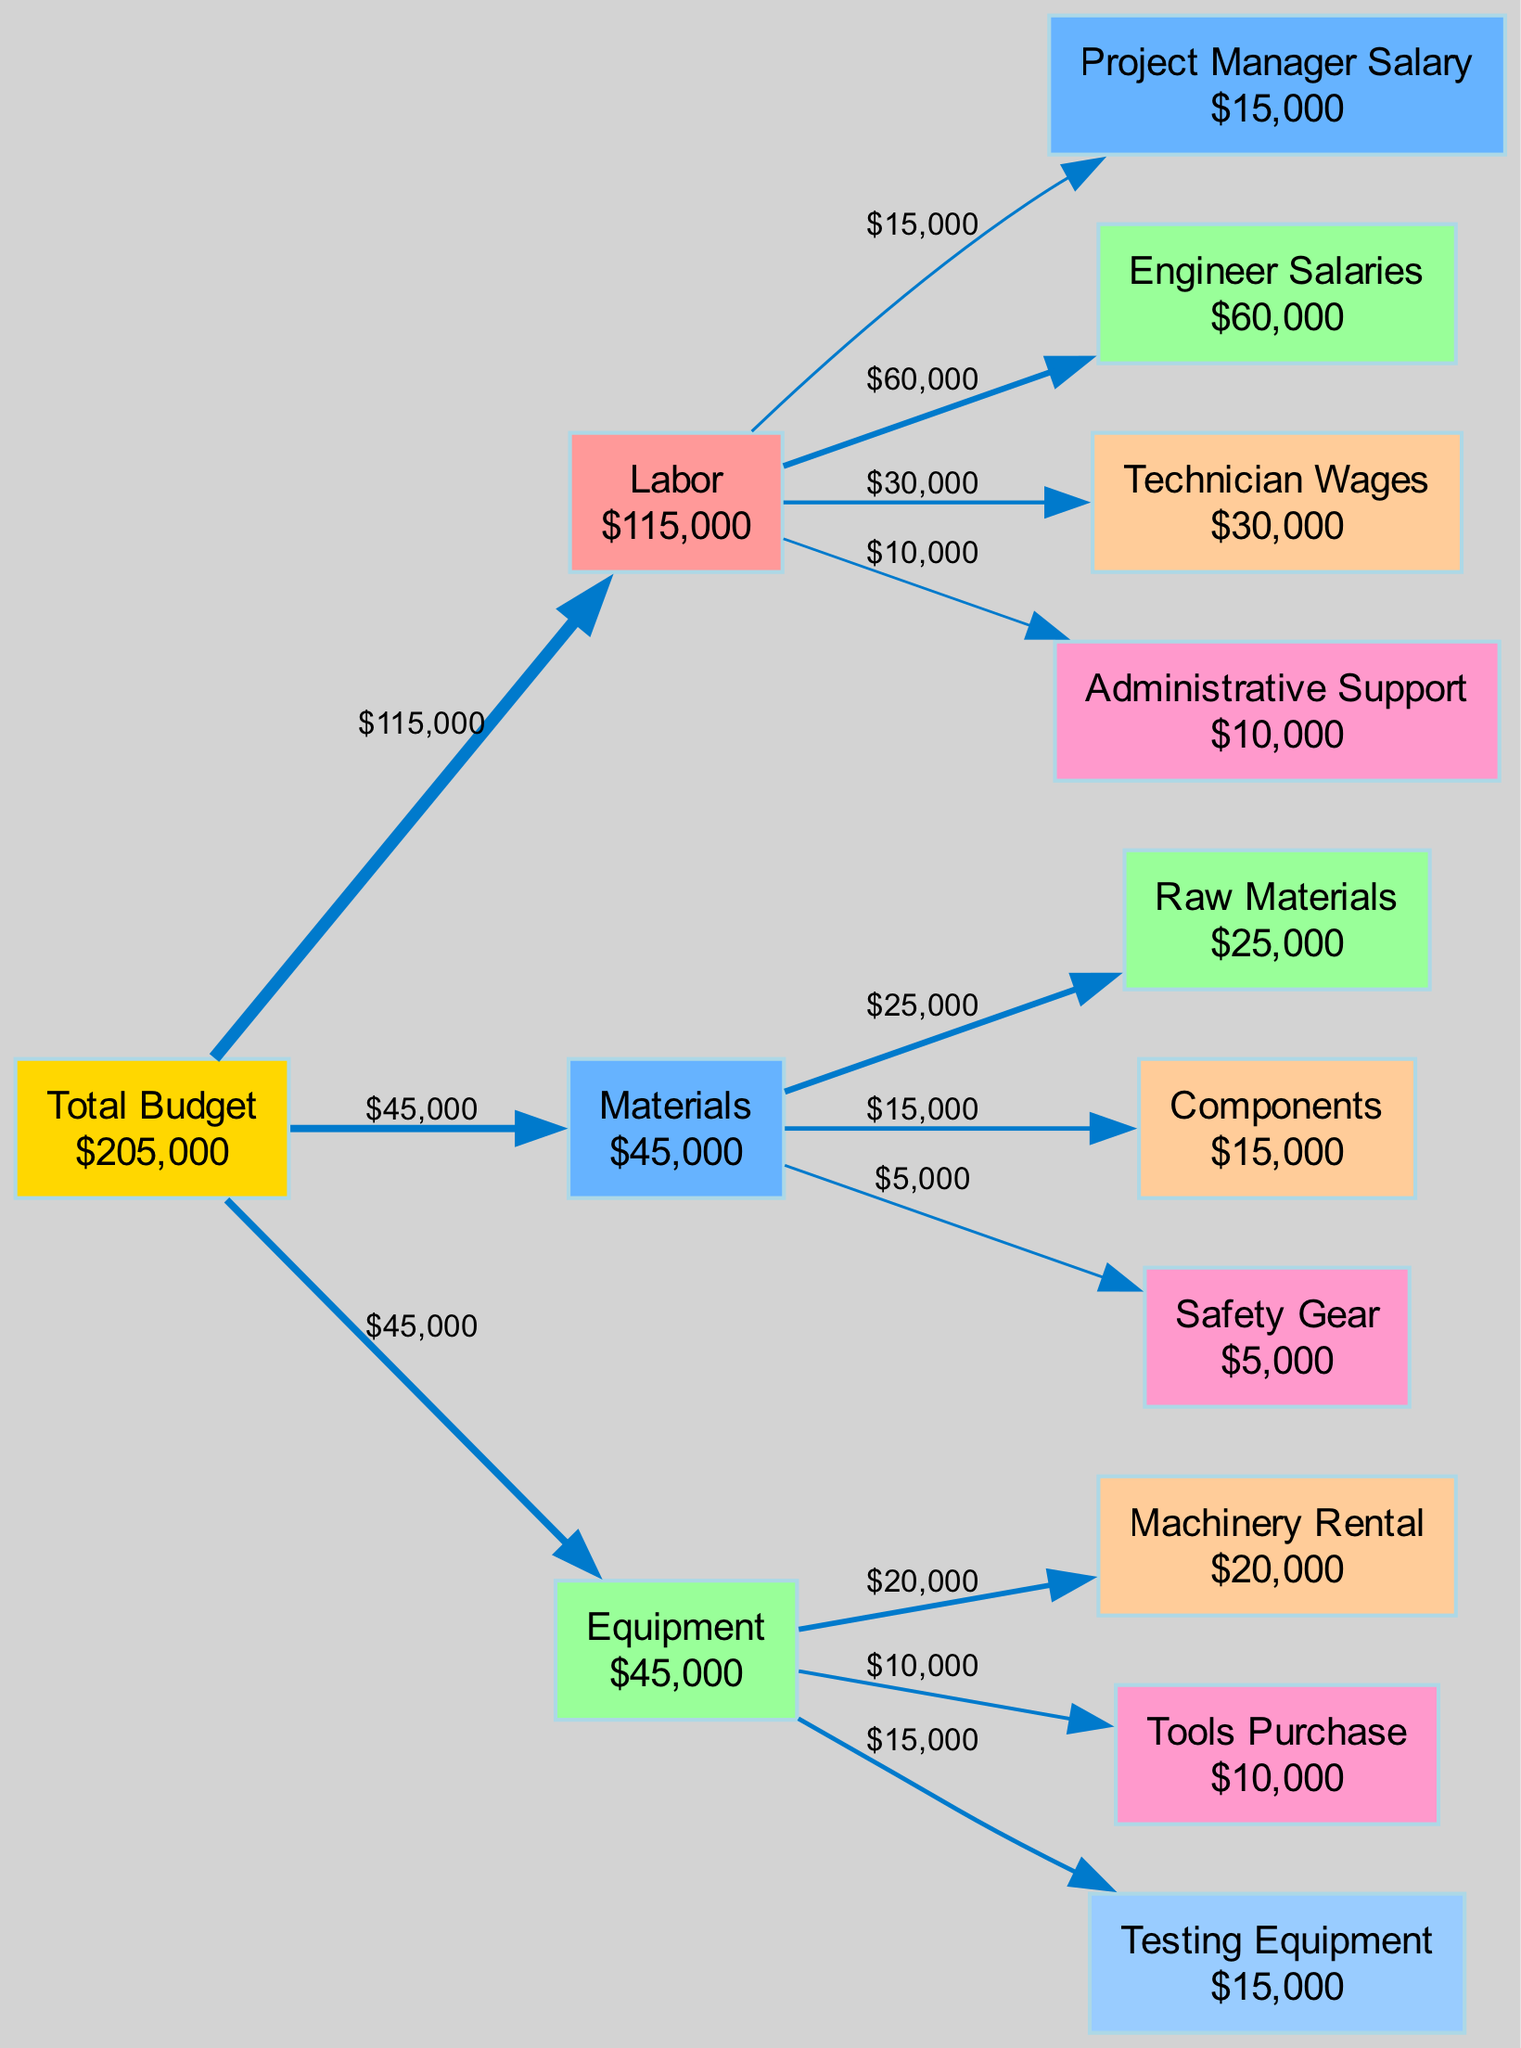What is the total budget for the project? The "Total Budget" node in the diagram displays the cumulative amount allocated for the entire project. By summing all expenses from Labor, Materials, and Equipment categories, we find that the total budget is $245,000.
Answer: $245,000 How much is allocated for Engineer Salaries? In the Labor category, the node for "Engineer Salaries" shows a specific amount. The diagram indicates that the allocation for this item is $60,000.
Answer: $60,000 Which category has the lowest total expenses? To determine this, we compare the total expenses in each category. The Materials category totals $40,000, while Labor totals $100,000 and Equipment totals $45,000, indicating that Materials has the lowest expenses.
Answer: Materials What percentage of the total budget is spent on Equipment? First, we look at the Equipment total of $45,000. We then calculate the percentage by dividing this amount by the total budget of $245,000 and multiplying by 100. This results in approximately 18.37%.
Answer: 18.37% How many items are listed under Labor? The Labor category contains four specific items: Project Manager Salary, Engineer Salaries, Technician Wages, and Administrative Support. By counting these items, we determine that there are four items listed.
Answer: 4 What is the total amount spent on Raw Materials and Components combined? We find the individual amounts for "Raw Materials" ($25,000) and "Components" ($15,000), then add these amounts together. The combined total is $40,000.
Answer: $40,000 Which item has the highest expense within the Materials category? In the Materials category, we compare the expenses of Raw Materials ($25,000), Components ($15,000), and Safety Gear ($5,000). The highest expense is for Raw Materials.
Answer: Raw Materials What is the total budget allocated for Labor? By summing the individual expense amounts in the Labor category: Project Manager Salary ($15,000), Engineer Salaries ($60,000), Technician Wages ($30,000), and Administrative Support ($10,000), we find the total allocation for Labor is $115,000.
Answer: $115,000 